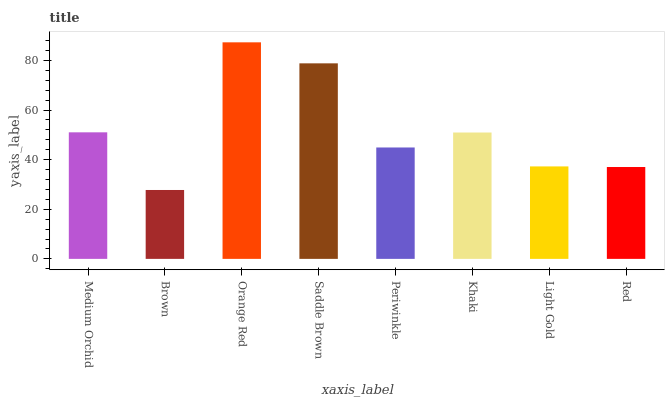Is Brown the minimum?
Answer yes or no. Yes. Is Orange Red the maximum?
Answer yes or no. Yes. Is Orange Red the minimum?
Answer yes or no. No. Is Brown the maximum?
Answer yes or no. No. Is Orange Red greater than Brown?
Answer yes or no. Yes. Is Brown less than Orange Red?
Answer yes or no. Yes. Is Brown greater than Orange Red?
Answer yes or no. No. Is Orange Red less than Brown?
Answer yes or no. No. Is Khaki the high median?
Answer yes or no. Yes. Is Periwinkle the low median?
Answer yes or no. Yes. Is Light Gold the high median?
Answer yes or no. No. Is Light Gold the low median?
Answer yes or no. No. 